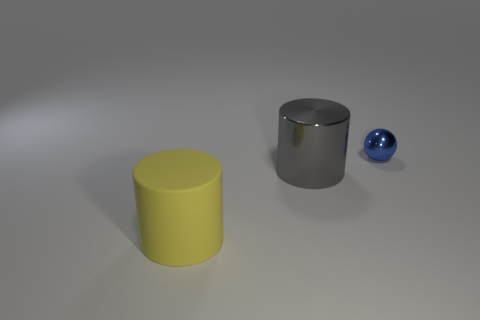Add 2 brown rubber cubes. How many objects exist? 5 Subtract all balls. How many objects are left? 2 Subtract all large yellow objects. Subtract all large green metallic cylinders. How many objects are left? 2 Add 1 big gray cylinders. How many big gray cylinders are left? 2 Add 1 metal objects. How many metal objects exist? 3 Subtract 0 brown cubes. How many objects are left? 3 